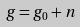Convert formula to latex. <formula><loc_0><loc_0><loc_500><loc_500>g = g _ { 0 } + n</formula> 